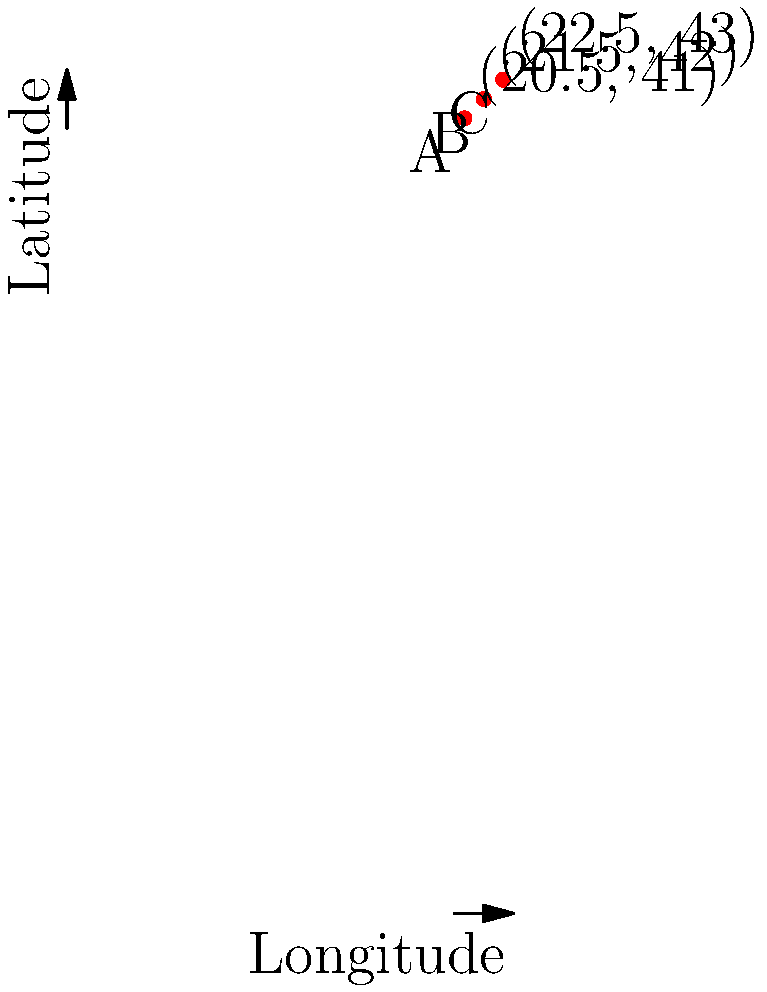Given the geographic coordinates of three Macedonian landmarks A (20.5°E, 41°N), B (21.5°E, 42°N), and C (22.5°E, 43°N), convert these to Cartesian coordinates assuming the Earth is a perfect sphere with a radius of 6,371 km. What is the Cartesian z-coordinate of landmark B in kilometers, rounded to the nearest whole number? To convert geographic coordinates to Cartesian coordinates, we use the following formulas:

1) $x = R \cos(\phi) \cos(\lambda)$
2) $y = R \cos(\phi) \sin(\lambda)$
3) $z = R \sin(\phi)$

Where:
- $R$ is the Earth's radius (6,371 km)
- $\phi$ is the latitude in radians
- $\lambda$ is the longitude in radians

For landmark B (21.5°E, 42°N):

1) Convert latitude and longitude to radians:
   $\phi = 42° * \frac{\pi}{180} = 0.7330$ radians
   $\lambda = 21.5° * \frac{\pi}{180} = 0.3752$ radians

2) Calculate z-coordinate:
   $z = R \sin(\phi)$
   $z = 6371 * \sin(0.7330)$
   $z = 6371 * 0.6691$
   $z = 4262.94$ km

3) Round to the nearest whole number:
   $z \approx 4263$ km
Answer: 4263 km 